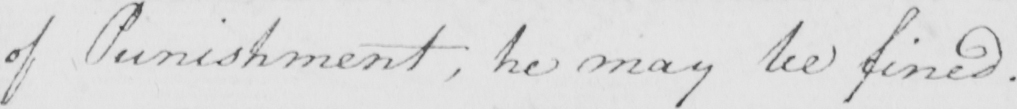Can you tell me what this handwritten text says? of Punishment , he may be fined . 